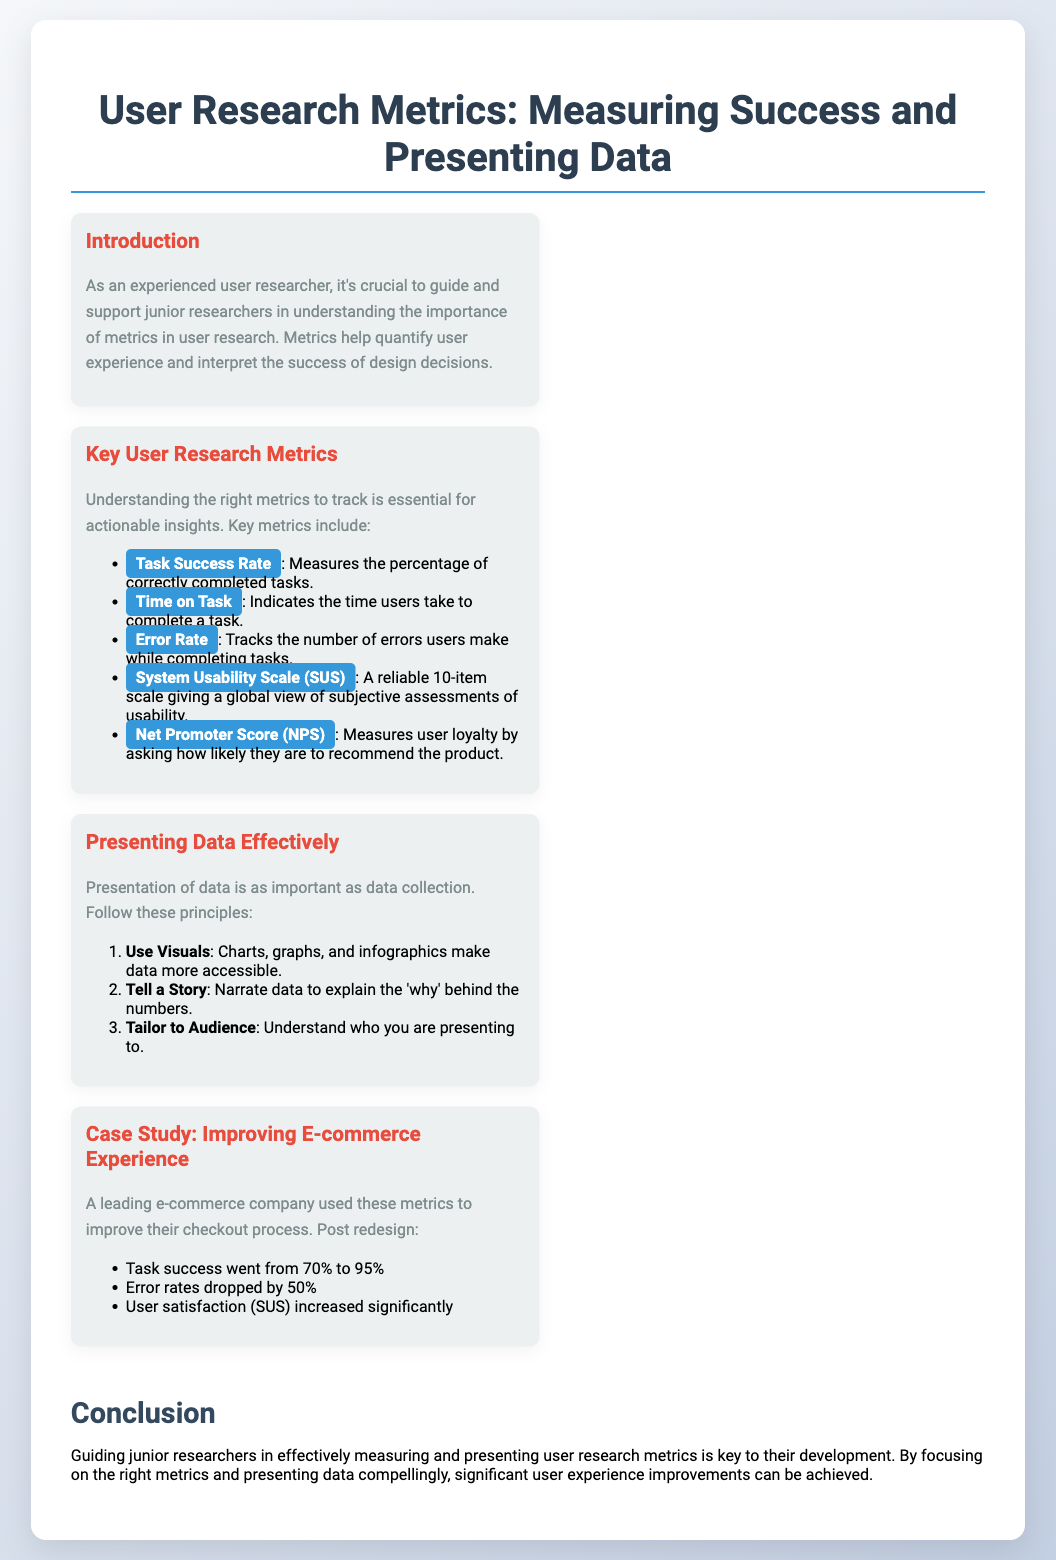What is the title of the presentation? The title is stated at the top of the slide.
Answer: User Research Metrics: Measuring Success and Presenting Data What are the two sections in the presentation layout? The sections are clearly labeled in the document.
Answer: Introduction and Key User Research Metrics What metric measures the percentage of correctly completed tasks? This is specified in the Key User Research Metrics section.
Answer: Task Success Rate What was the error rate reduction percentage achieved in the case study? This is mentioned as an outcome in the Case Study section.
Answer: 50% What does NPS stand for? This is defined in the Key User Research Metrics section.
Answer: Net Promoter Score How many items are on the System Usability Scale? This information is provided in the description of SUS metrics.
Answer: 10-item What was the Task Success Rate after the redesign in the case study? This figure is presented in the results of the case study.
Answer: 95% What is one principle for presenting data effectively? One of the principles is listed in the Presenting Data Effectively section.
Answer: Use Visuals What color is used for the section titles? The color of the section titles is specified in the document style.
Answer: Red 